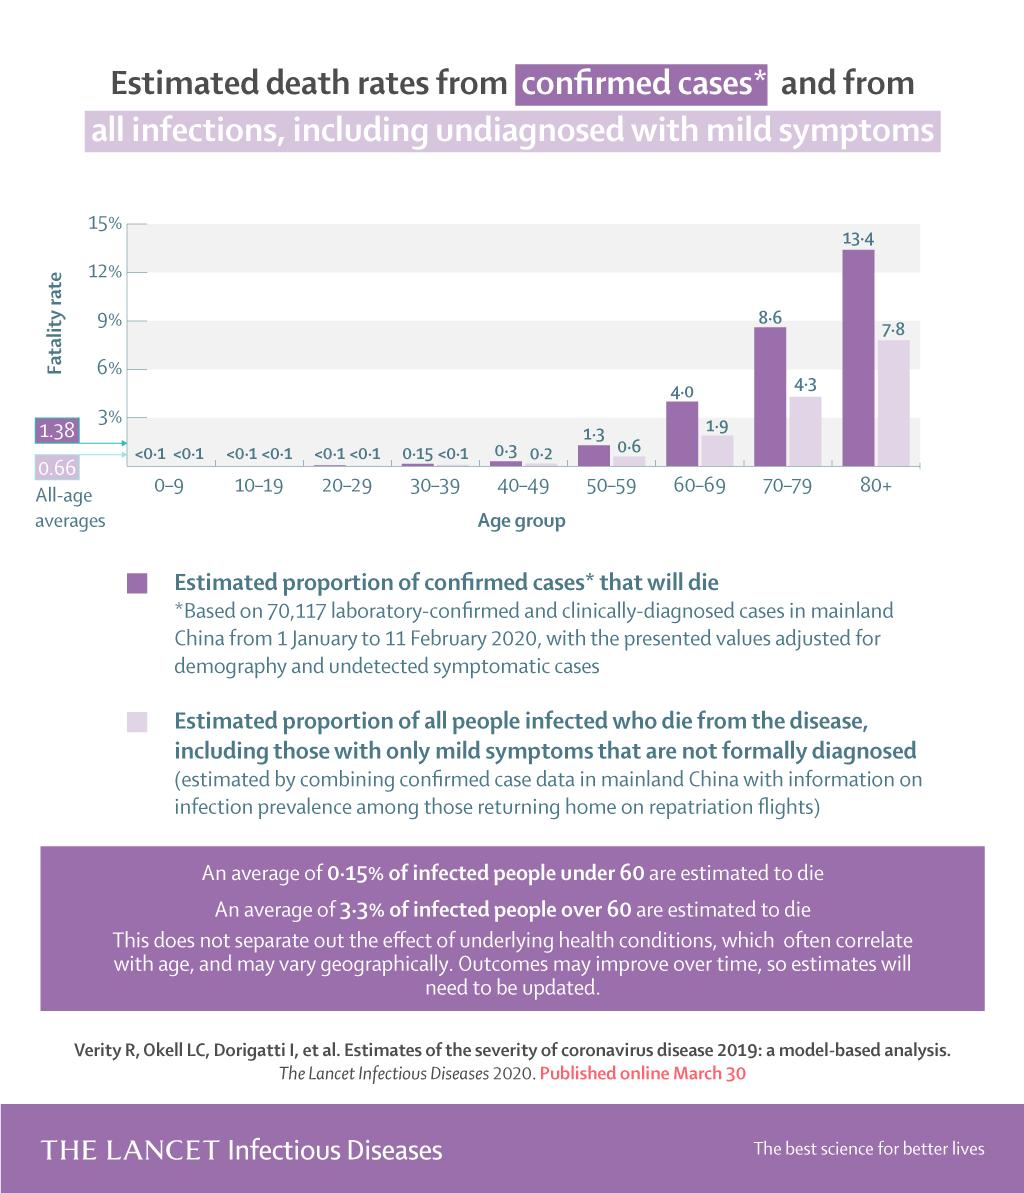Identify some key points in this picture. According to estimates, 26% of confirmed cases above the age of 60 are predicted to die. 